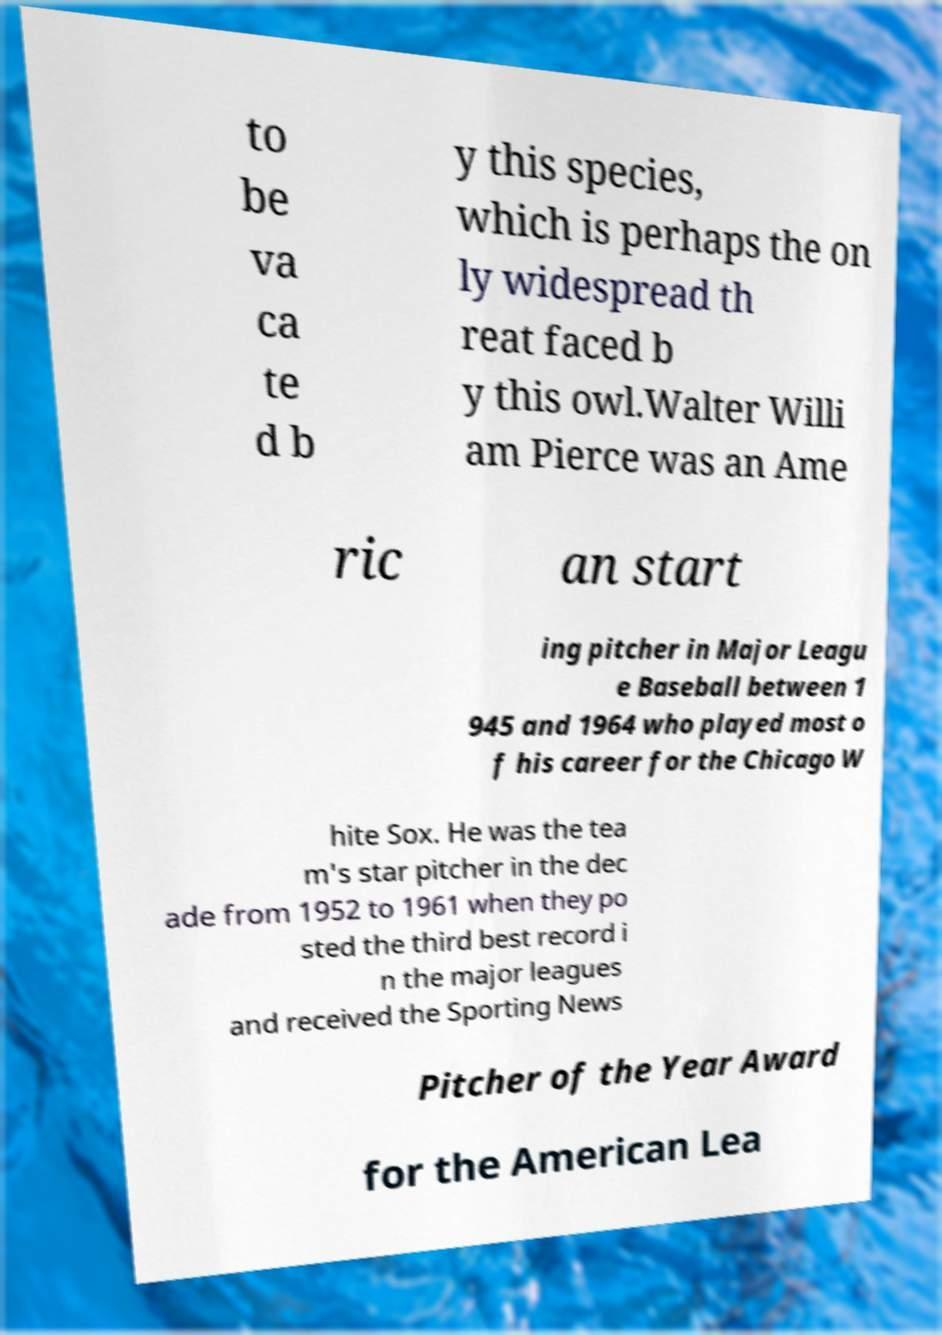Please identify and transcribe the text found in this image. to be va ca te d b y this species, which is perhaps the on ly widespread th reat faced b y this owl.Walter Willi am Pierce was an Ame ric an start ing pitcher in Major Leagu e Baseball between 1 945 and 1964 who played most o f his career for the Chicago W hite Sox. He was the tea m's star pitcher in the dec ade from 1952 to 1961 when they po sted the third best record i n the major leagues and received the Sporting News Pitcher of the Year Award for the American Lea 